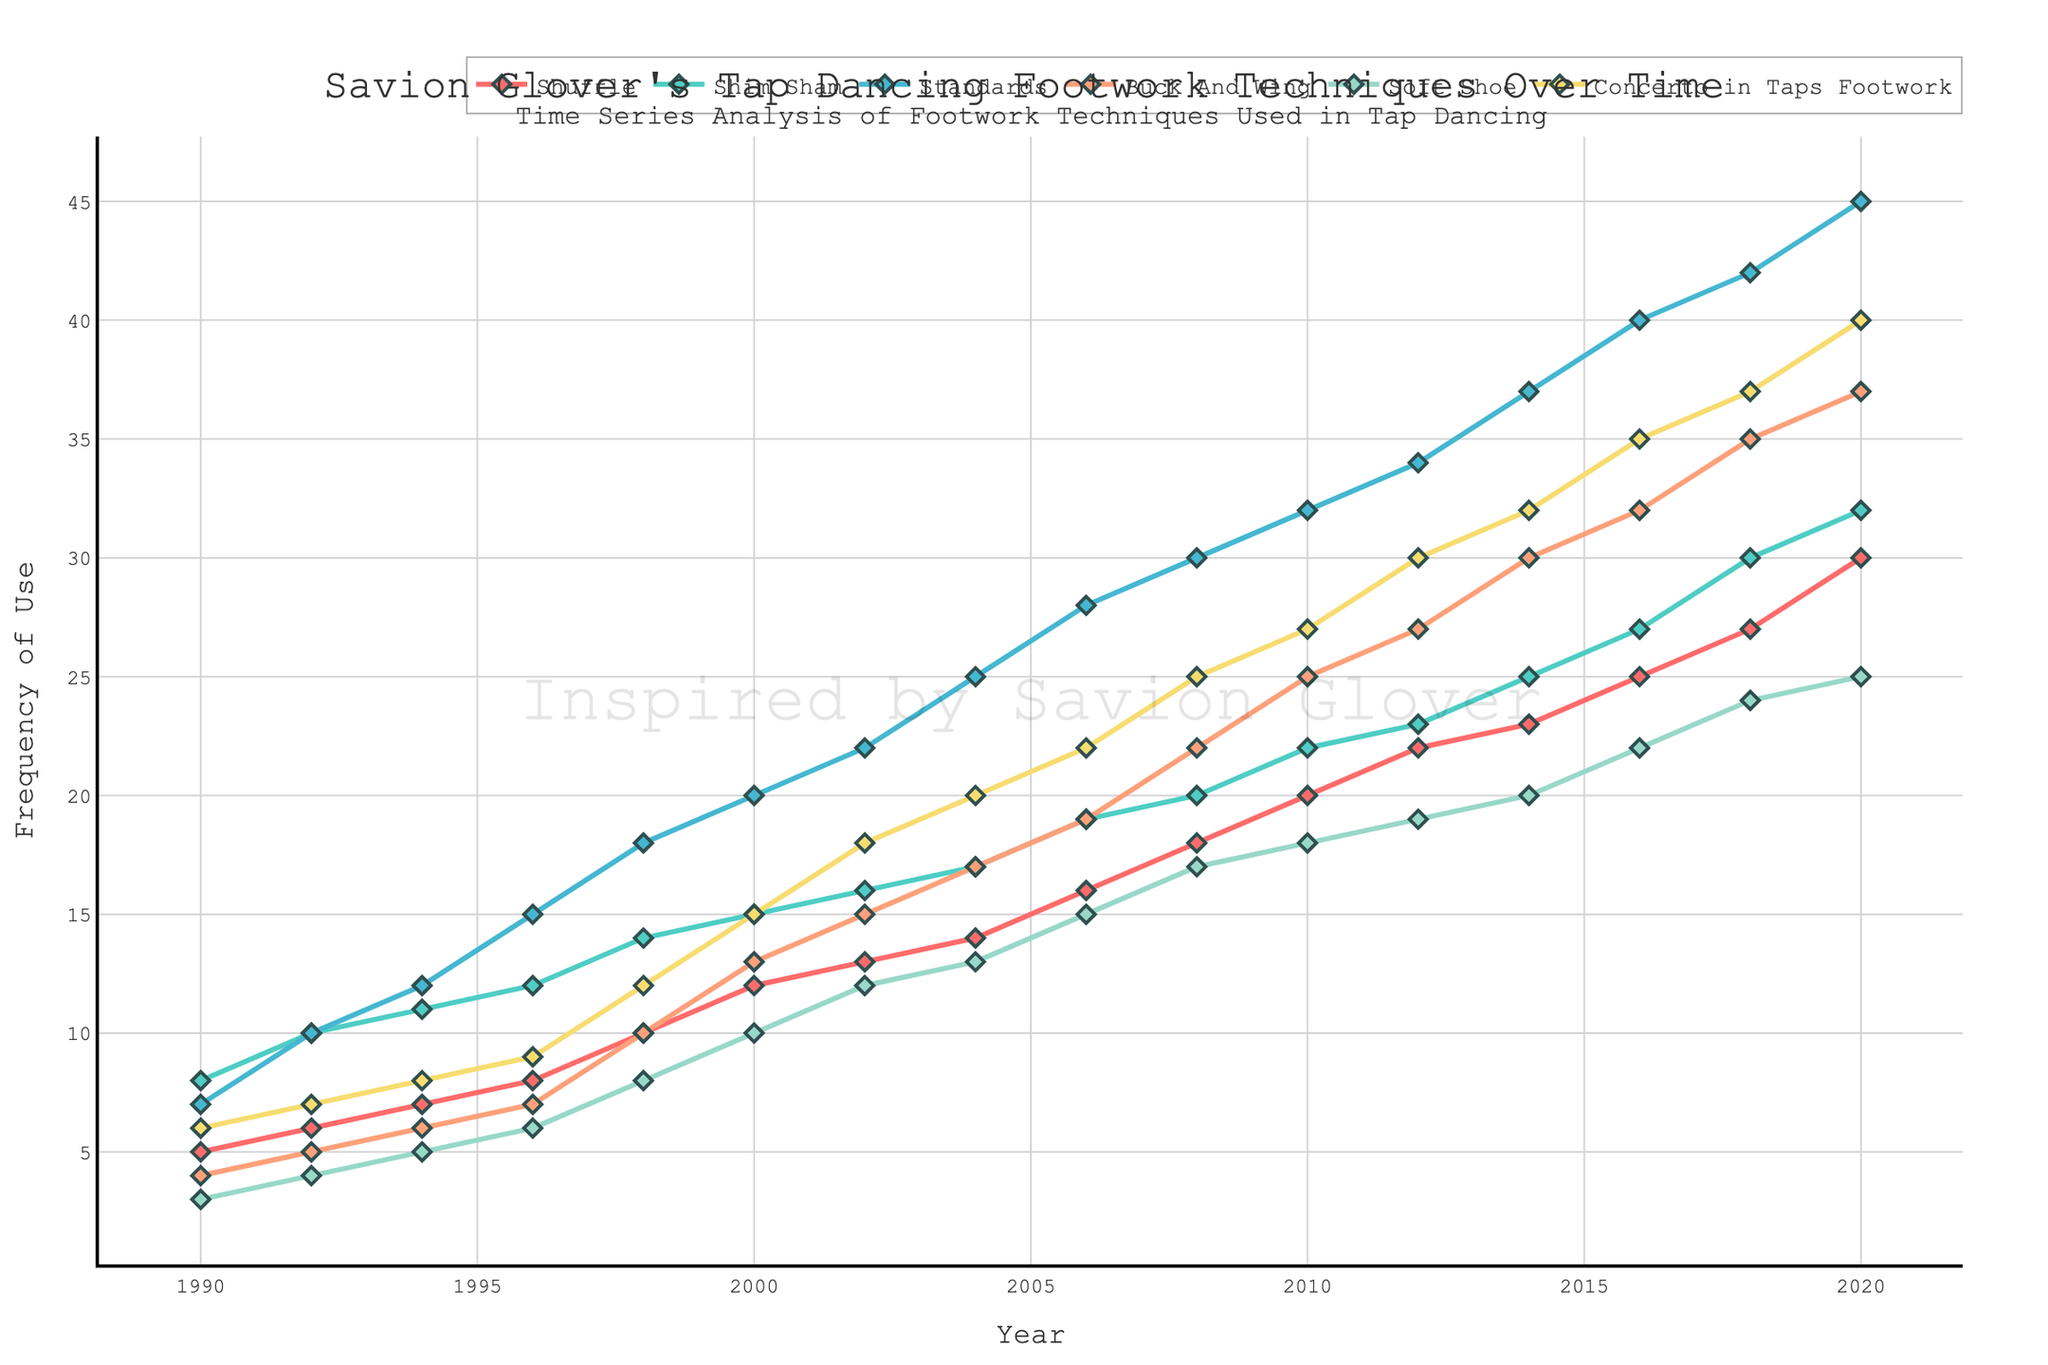What is the title of the plot? The title is located at the top center of the plot. It reads "Savion Glover's Tap Dancing Footwork Techniques Over Time."
Answer: Savion Glover's Tap Dancing Footwork Techniques Over Time What color is used for the 'Shuffle' technique's line? By looking at the plot's legend and its corresponding line color, the 'Shuffle' technique is represented by a shade of red.
Answer: Red How many data points are there for each footwork technique? Each technique is plotted against every year listed, from 1990 to 2020, equating to a total of 16 data points per technique.
Answer: 16 Which footwork technique had the highest frequency of use in 2020? By examining the highest points at the far right of the plot, it is noticeable that the 'Standards' technique reached the highest value in 2020.
Answer: Standards What is the least used footwork technique in 1990? Focus on the leftmost data points for 1990 on the plot. The values can be observed to determine that the 'Soft Shoe' technique had the least frequency of use in 1990.
Answer: Soft Shoe What is the overall trend for the 'Shim Sham' technique? Observing the trajectory of the 'Shim Sham' line from start to finish, it consistently rises, indicating an increasing trend.
Answer: Increasing Between which years did the 'Concerto in Taps Footwork' technique see the largest increase in use? Look for the steepest slope in the line representing 'Concerto in Taps Footwork'. The steepest increase occurs between 1998 and 2000.
Answer: 1998 and 2000 How does the frequency of 'Standards' in 2000 compare to that in 1992? Compare the value of the 'Standards' line at the years 2000 and 1992 respectively. It shows that it increased from 10 in 1992 to 20 in 2000.
Answer: Increased What is the average frequency of 'Buck And Wing' use from 1990 to 2000? Adding the 'Buck And Wing' values from 1990 to 2000 gives (4 + 5 + 6 + 7 + 10 + 13) = 45. The average is then 45/6.
Answer: 7.5 Between which years did 'Soft Shoe' experience a noticeable plateau? Identify segments of the 'Soft Shoe' line that remain relatively flat. It appears to plateau between 2010 and 2014.
Answer: 2010 and 2014 